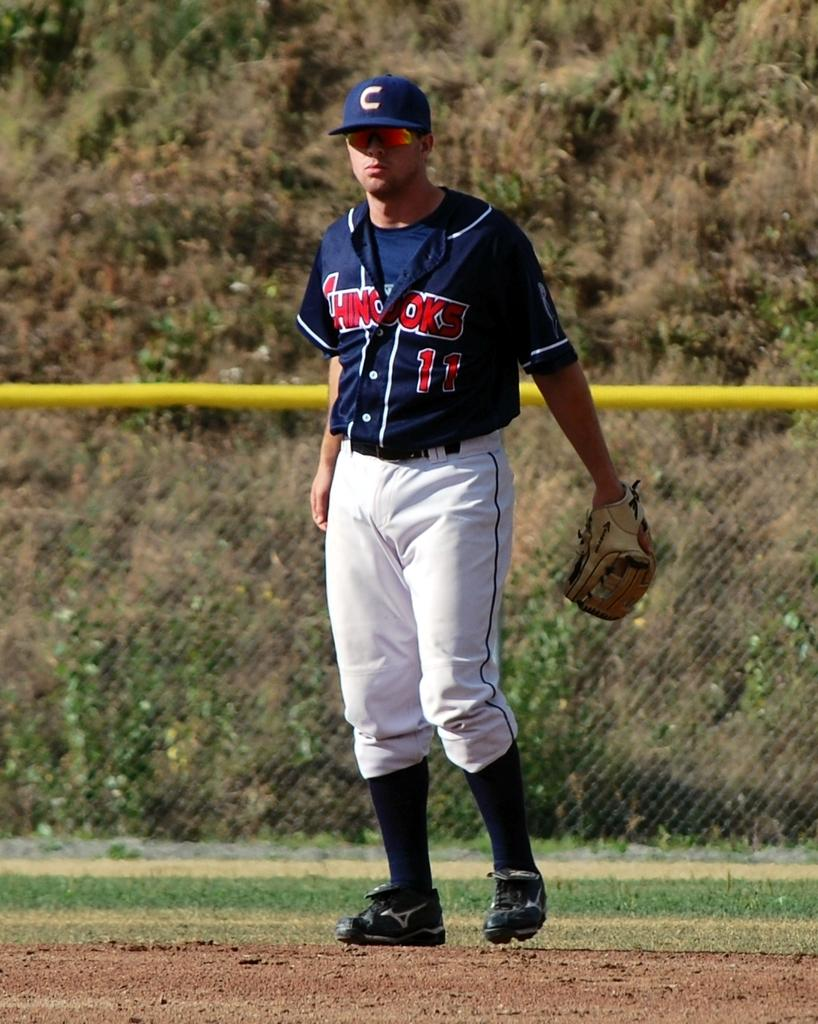What is the main subject of the image? There is a person standing in the image. What is the person standing on? The person is standing on the ground. What is the person wearing on their hand? The person is wearing a glove. What can be seen in the background of the image? There is a fence and trees in the background of the image. What word is the person trying to communicate in the image? There is no indication in the image that the person is trying to communicate a specific word. 